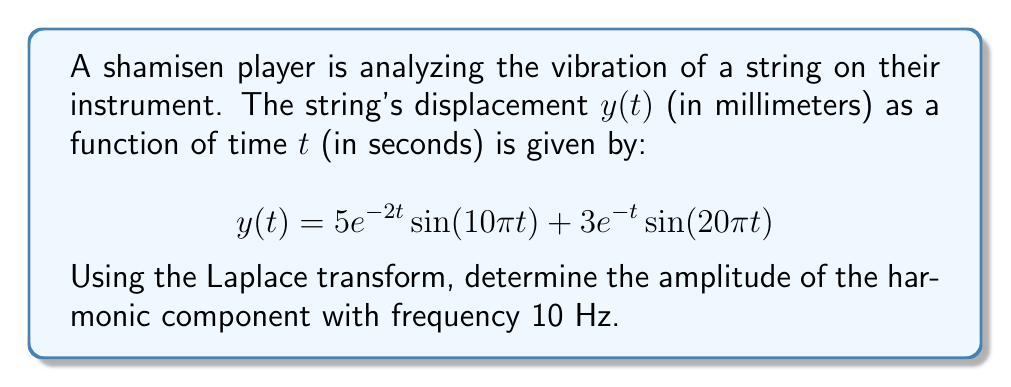Teach me how to tackle this problem. To solve this problem, we'll follow these steps:

1) First, recall the Laplace transform of a damped sinusoidal function:
   $$\mathcal{L}\{e^{-at}\sin(bt)\} = \frac{b}{(s+a)^2 + b^2}$$

2) The given function $y(t)$ consists of two terms. Let's transform each separately:

   For the first term: $5e^{-2t}\sin(10\pi t)$
   $a = 2$, $b = 10\pi$
   $$\mathcal{L}\{5e^{-2t}\sin(10\pi t)\} = 5 \cdot \frac{10\pi}{(s+2)^2 + (10\pi)^2}$$

   For the second term: $3e^{-t}\sin(20\pi t)$
   $a = 1$, $b = 20\pi$
   $$\mathcal{L}\{3e^{-t}\sin(20\pi t)\} = 3 \cdot \frac{20\pi}{(s+1)^2 + (20\pi)^2}$$

3) The Laplace transform of $y(t)$ is the sum of these two terms:

   $$Y(s) = \frac{50\pi}{(s+2)^2 + (10\pi)^2} + \frac{60\pi}{(s+1)^2 + (20\pi)^2}$$

4) To find the amplitude of the harmonic component with frequency 10 Hz, we need to look at the first term, as it corresponds to $\sin(10\pi t)$ (note that $10\pi$ radians/second = 5 Hz).

5) The amplitude of this component is the coefficient of the sine term in the time domain, which is 5.

Therefore, the amplitude of the harmonic component with frequency 10 Hz is 5 mm.
Answer: 5 mm 